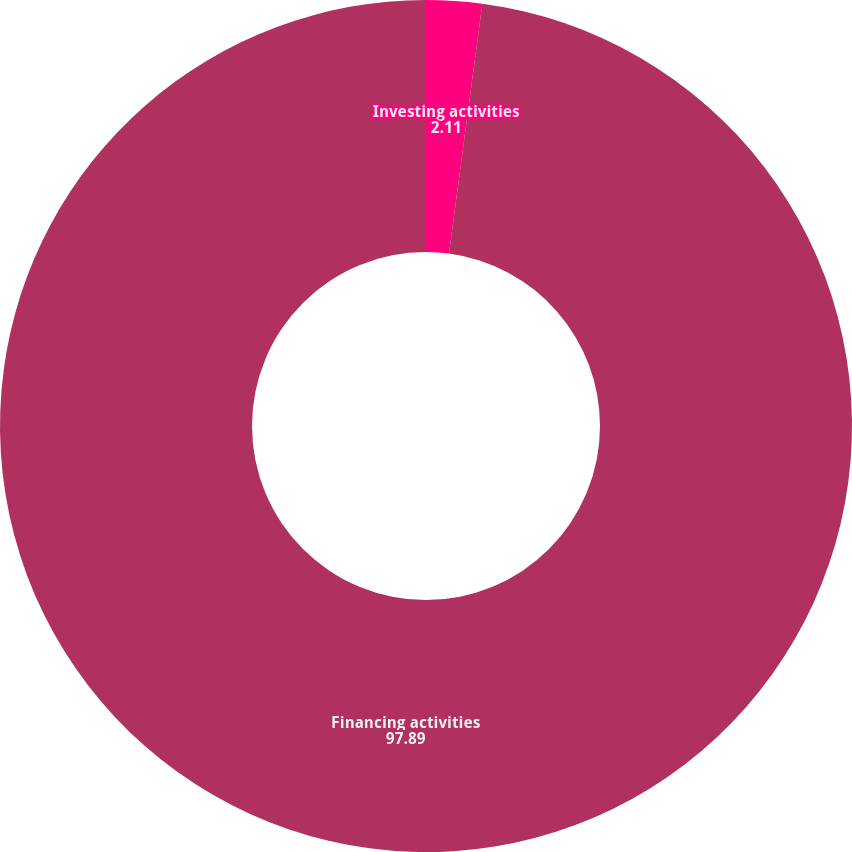<chart> <loc_0><loc_0><loc_500><loc_500><pie_chart><fcel>Investing activities<fcel>Financing activities<nl><fcel>2.11%<fcel>97.89%<nl></chart> 